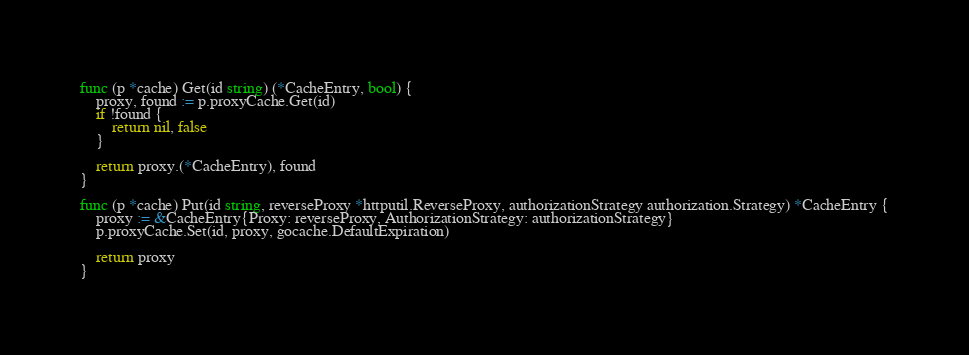<code> <loc_0><loc_0><loc_500><loc_500><_Go_>func (p *cache) Get(id string) (*CacheEntry, bool) {
	proxy, found := p.proxyCache.Get(id)
	if !found {
		return nil, false
	}

	return proxy.(*CacheEntry), found
}

func (p *cache) Put(id string, reverseProxy *httputil.ReverseProxy, authorizationStrategy authorization.Strategy) *CacheEntry {
	proxy := &CacheEntry{Proxy: reverseProxy, AuthorizationStrategy: authorizationStrategy}
	p.proxyCache.Set(id, proxy, gocache.DefaultExpiration)

	return proxy
}
</code> 